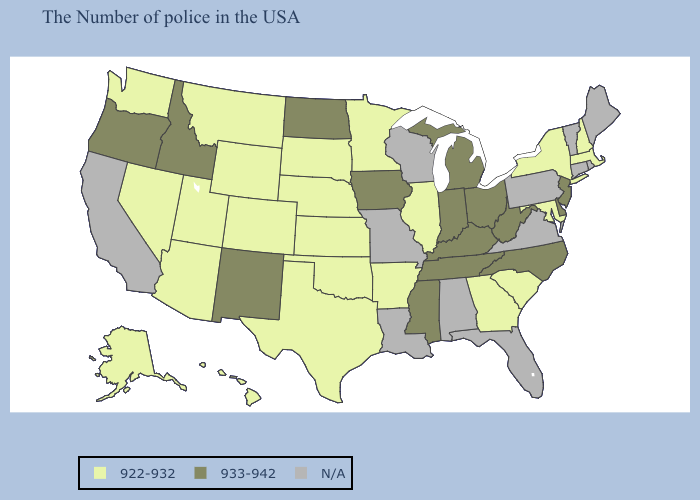Does the first symbol in the legend represent the smallest category?
Answer briefly. Yes. What is the lowest value in the Northeast?
Keep it brief. 922-932. Does New Jersey have the lowest value in the Northeast?
Concise answer only. No. Name the states that have a value in the range N/A?
Keep it brief. Maine, Rhode Island, Vermont, Connecticut, Pennsylvania, Virginia, Florida, Alabama, Wisconsin, Louisiana, Missouri, California. Name the states that have a value in the range 922-932?
Concise answer only. Massachusetts, New Hampshire, New York, Maryland, South Carolina, Georgia, Illinois, Arkansas, Minnesota, Kansas, Nebraska, Oklahoma, Texas, South Dakota, Wyoming, Colorado, Utah, Montana, Arizona, Nevada, Washington, Alaska, Hawaii. Which states have the lowest value in the USA?
Give a very brief answer. Massachusetts, New Hampshire, New York, Maryland, South Carolina, Georgia, Illinois, Arkansas, Minnesota, Kansas, Nebraska, Oklahoma, Texas, South Dakota, Wyoming, Colorado, Utah, Montana, Arizona, Nevada, Washington, Alaska, Hawaii. Name the states that have a value in the range 922-932?
Keep it brief. Massachusetts, New Hampshire, New York, Maryland, South Carolina, Georgia, Illinois, Arkansas, Minnesota, Kansas, Nebraska, Oklahoma, Texas, South Dakota, Wyoming, Colorado, Utah, Montana, Arizona, Nevada, Washington, Alaska, Hawaii. What is the value of Oregon?
Keep it brief. 933-942. Among the states that border Kansas , which have the lowest value?
Keep it brief. Nebraska, Oklahoma, Colorado. Name the states that have a value in the range 922-932?
Answer briefly. Massachusetts, New Hampshire, New York, Maryland, South Carolina, Georgia, Illinois, Arkansas, Minnesota, Kansas, Nebraska, Oklahoma, Texas, South Dakota, Wyoming, Colorado, Utah, Montana, Arizona, Nevada, Washington, Alaska, Hawaii. Which states have the lowest value in the MidWest?
Short answer required. Illinois, Minnesota, Kansas, Nebraska, South Dakota. What is the highest value in the USA?
Be succinct. 933-942. What is the value of Minnesota?
Short answer required. 922-932. Name the states that have a value in the range 933-942?
Keep it brief. New Jersey, Delaware, North Carolina, West Virginia, Ohio, Michigan, Kentucky, Indiana, Tennessee, Mississippi, Iowa, North Dakota, New Mexico, Idaho, Oregon. 